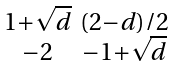Convert formula to latex. <formula><loc_0><loc_0><loc_500><loc_500>\begin{smallmatrix} 1 + \sqrt { d } & ( 2 - d ) / 2 \\ - 2 & - 1 + \sqrt { d } \end{smallmatrix}</formula> 